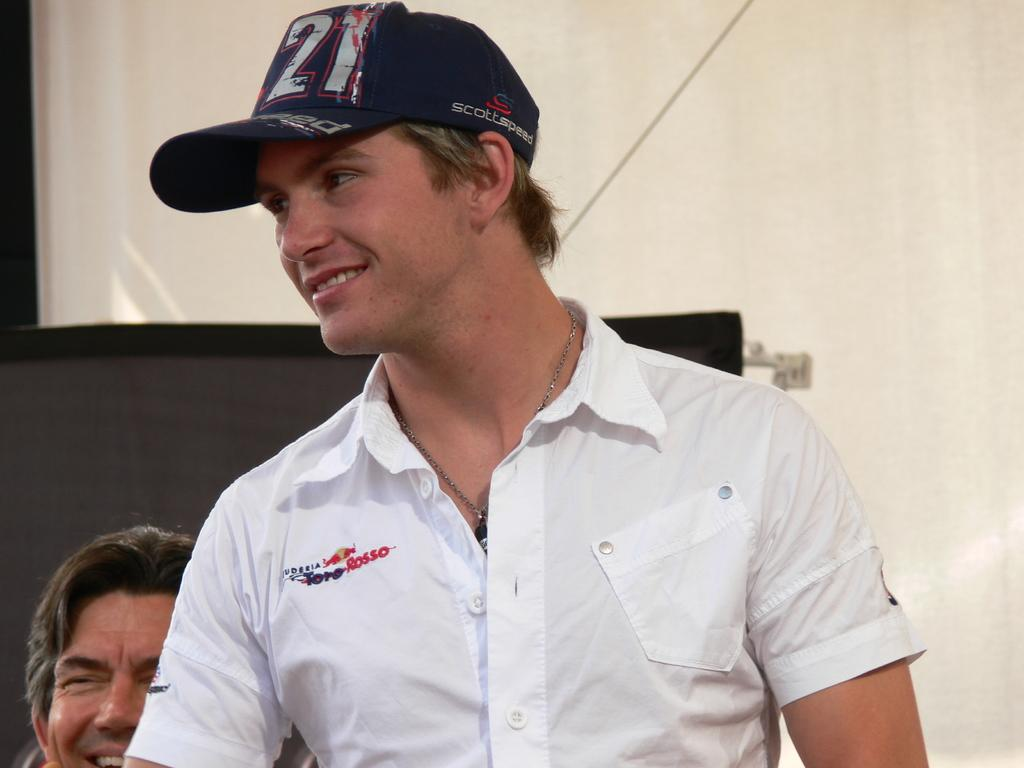<image>
Offer a succinct explanation of the picture presented. a person with a whit shirt that says Rosso on it 